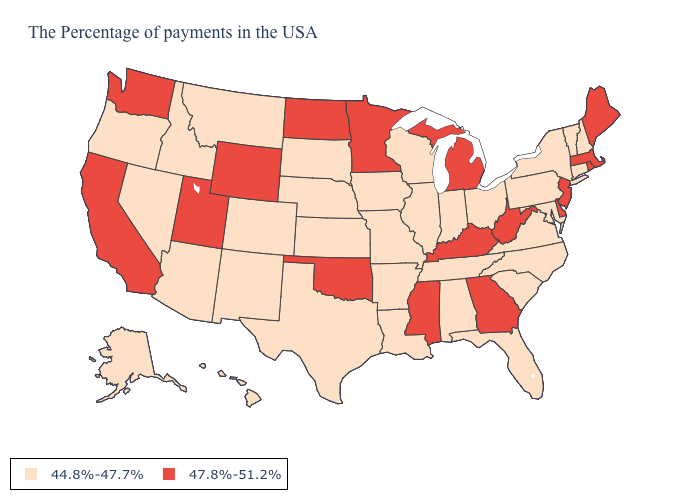Name the states that have a value in the range 47.8%-51.2%?
Quick response, please. Maine, Massachusetts, Rhode Island, New Jersey, Delaware, West Virginia, Georgia, Michigan, Kentucky, Mississippi, Minnesota, Oklahoma, North Dakota, Wyoming, Utah, California, Washington. Among the states that border Michigan , which have the highest value?
Write a very short answer. Ohio, Indiana, Wisconsin. What is the value of Missouri?
Write a very short answer. 44.8%-47.7%. What is the value of Tennessee?
Short answer required. 44.8%-47.7%. Among the states that border Kansas , does Oklahoma have the highest value?
Write a very short answer. Yes. Does Massachusetts have the highest value in the USA?
Be succinct. Yes. Which states have the lowest value in the USA?
Answer briefly. New Hampshire, Vermont, Connecticut, New York, Maryland, Pennsylvania, Virginia, North Carolina, South Carolina, Ohio, Florida, Indiana, Alabama, Tennessee, Wisconsin, Illinois, Louisiana, Missouri, Arkansas, Iowa, Kansas, Nebraska, Texas, South Dakota, Colorado, New Mexico, Montana, Arizona, Idaho, Nevada, Oregon, Alaska, Hawaii. Which states have the lowest value in the Northeast?
Concise answer only. New Hampshire, Vermont, Connecticut, New York, Pennsylvania. Name the states that have a value in the range 47.8%-51.2%?
Keep it brief. Maine, Massachusetts, Rhode Island, New Jersey, Delaware, West Virginia, Georgia, Michigan, Kentucky, Mississippi, Minnesota, Oklahoma, North Dakota, Wyoming, Utah, California, Washington. Is the legend a continuous bar?
Concise answer only. No. Which states have the highest value in the USA?
Give a very brief answer. Maine, Massachusetts, Rhode Island, New Jersey, Delaware, West Virginia, Georgia, Michigan, Kentucky, Mississippi, Minnesota, Oklahoma, North Dakota, Wyoming, Utah, California, Washington. What is the value of Kentucky?
Concise answer only. 47.8%-51.2%. Among the states that border Kentucky , which have the lowest value?
Keep it brief. Virginia, Ohio, Indiana, Tennessee, Illinois, Missouri. Does Kansas have a lower value than Michigan?
Keep it brief. Yes. What is the value of Arizona?
Keep it brief. 44.8%-47.7%. 